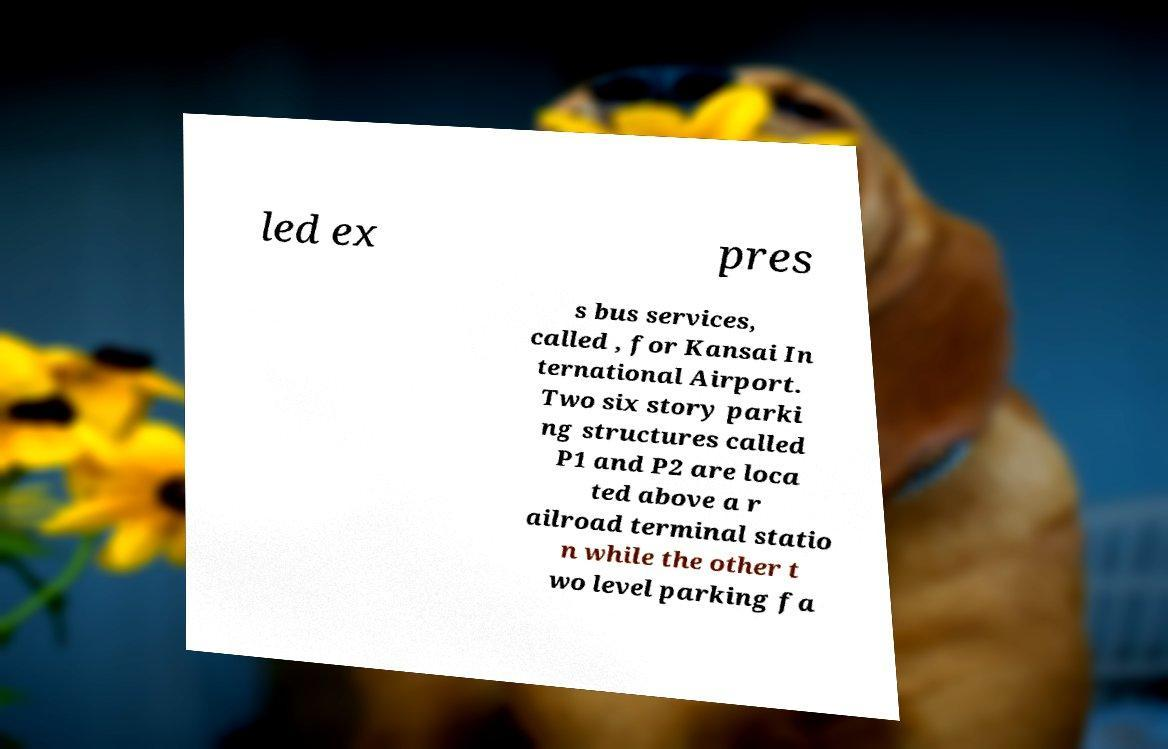Can you read and provide the text displayed in the image?This photo seems to have some interesting text. Can you extract and type it out for me? led ex pres s bus services, called , for Kansai In ternational Airport. Two six story parki ng structures called P1 and P2 are loca ted above a r ailroad terminal statio n while the other t wo level parking fa 